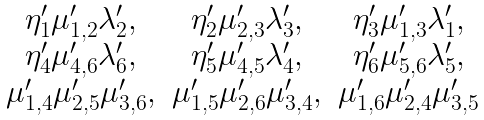<formula> <loc_0><loc_0><loc_500><loc_500>\begin{array} [ h ] { c c c } \eta ^ { \prime } _ { 1 } \mu ^ { \prime } _ { 1 , 2 } \lambda ^ { \prime } _ { 2 } , & \eta ^ { \prime } _ { 2 } \mu ^ { \prime } _ { 2 , 3 } \lambda ^ { \prime } _ { 3 } , & \eta ^ { \prime } _ { 3 } \mu ^ { \prime } _ { 1 , 3 } \lambda ^ { \prime } _ { 1 } , \\ \eta ^ { \prime } _ { 4 } \mu ^ { \prime } _ { 4 , 6 } \lambda ^ { \prime } _ { 6 } , & \eta ^ { \prime } _ { 5 } \mu ^ { \prime } _ { 4 , 5 } \lambda ^ { \prime } _ { 4 } , & \eta ^ { \prime } _ { 6 } \mu ^ { \prime } _ { 5 , 6 } \lambda ^ { \prime } _ { 5 } , \\ \mu ^ { \prime } _ { 1 , 4 } \mu ^ { \prime } _ { 2 , 5 } \mu ^ { \prime } _ { 3 , 6 } , & \mu ^ { \prime } _ { 1 , 5 } \mu ^ { \prime } _ { 2 , 6 } \mu ^ { \prime } _ { 3 , 4 } , & \mu ^ { \prime } _ { 1 , 6 } \mu ^ { \prime } _ { 2 , 4 } \mu ^ { \prime } _ { 3 , 5 } \end{array}</formula> 